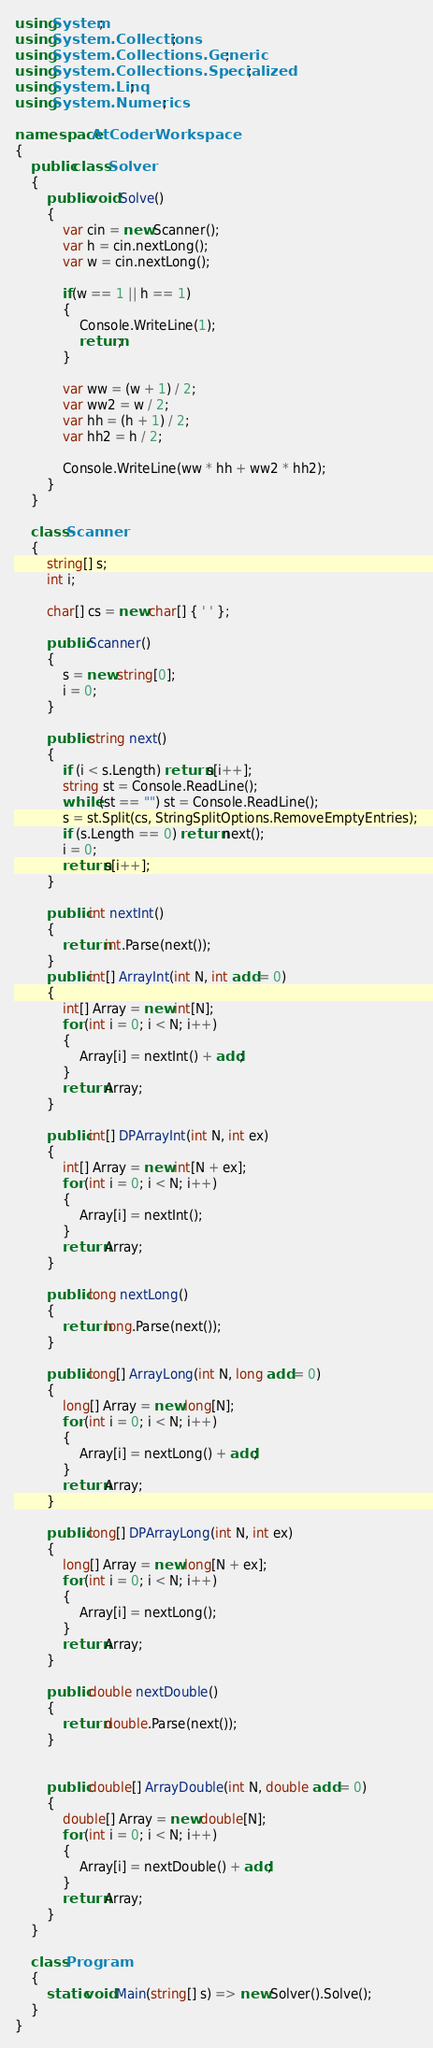Convert code to text. <code><loc_0><loc_0><loc_500><loc_500><_C#_>using System;
using System.Collections;
using System.Collections.Generic;
using System.Collections.Specialized;
using System.Linq;
using System.Numerics;

namespace AtCoderWorkspace
{
    public class Solver
    {
        public void Solve()
        {
            var cin = new Scanner();
            var h = cin.nextLong();
            var w = cin.nextLong();

            if(w == 1 || h == 1)
            {
                Console.WriteLine(1);
                return;
            }

            var ww = (w + 1) / 2;
            var ww2 = w / 2;
            var hh = (h + 1) / 2;
            var hh2 = h / 2;            
            
            Console.WriteLine(ww * hh + ww2 * hh2);
        }
    }

    class Scanner
    {
        string[] s;
        int i;

        char[] cs = new char[] { ' ' };

        public Scanner()
        {
            s = new string[0];
            i = 0;
        }

        public string next()
        {
            if (i < s.Length) return s[i++];
            string st = Console.ReadLine();
            while (st == "") st = Console.ReadLine();
            s = st.Split(cs, StringSplitOptions.RemoveEmptyEntries);
            if (s.Length == 0) return next();
            i = 0;
            return s[i++];
        }

        public int nextInt()
        {
            return int.Parse(next());
        }
        public int[] ArrayInt(int N, int add = 0)
        {
            int[] Array = new int[N];
            for (int i = 0; i < N; i++)
            {
                Array[i] = nextInt() + add;
            }
            return Array;
        }

        public int[] DPArrayInt(int N, int ex)
        {
            int[] Array = new int[N + ex];
            for (int i = 0; i < N; i++)
            {
                Array[i] = nextInt();
            }
            return Array;
        }

        public long nextLong()
        {
            return long.Parse(next());
        }

        public long[] ArrayLong(int N, long add = 0)
        {
            long[] Array = new long[N];
            for (int i = 0; i < N; i++)
            {
                Array[i] = nextLong() + add;
            }
            return Array;
        }

        public long[] DPArrayLong(int N, int ex)
        {
            long[] Array = new long[N + ex];
            for (int i = 0; i < N; i++)
            {
                Array[i] = nextLong();
            }
            return Array;
        }

        public double nextDouble()
        {
            return double.Parse(next());
        }


        public double[] ArrayDouble(int N, double add = 0)
        {
            double[] Array = new double[N];
            for (int i = 0; i < N; i++)
            {
                Array[i] = nextDouble() + add;
            }
            return Array;
        }
    }

    class Program
    {
        static void Main(string[] s) => new Solver().Solve();
    }
}
</code> 